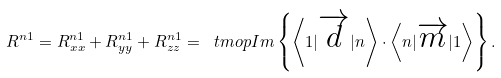Convert formula to latex. <formula><loc_0><loc_0><loc_500><loc_500>R ^ { n 1 } = R ^ { n 1 } _ { x x } + R ^ { n 1 } _ { y y } + R ^ { n 1 } _ { z z } = \ t m o p { I m } \left \{ \left \langle 1 | \overrightarrow { d } | n \right \rangle \cdot \left \langle n | \overrightarrow { m } | 1 \right \rangle \right \} .</formula> 